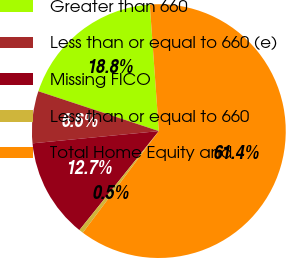Convert chart to OTSL. <chart><loc_0><loc_0><loc_500><loc_500><pie_chart><fcel>Greater than 660<fcel>Less than or equal to 660 (e)<fcel>Missing FICO<fcel>Less than or equal to 660<fcel>Total Home Equity and<nl><fcel>18.78%<fcel>6.62%<fcel>12.7%<fcel>0.54%<fcel>61.35%<nl></chart> 